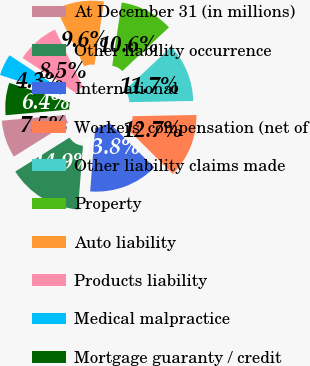Convert chart. <chart><loc_0><loc_0><loc_500><loc_500><pie_chart><fcel>At December 31 (in millions)<fcel>Other liability occurrence<fcel>International<fcel>Workers' compensation (net of<fcel>Other liability claims made<fcel>Property<fcel>Auto liability<fcel>Products liability<fcel>Medical malpractice<fcel>Mortgage guaranty / credit<nl><fcel>7.47%<fcel>14.86%<fcel>13.8%<fcel>12.74%<fcel>11.69%<fcel>10.63%<fcel>9.58%<fcel>8.52%<fcel>4.3%<fcel>6.41%<nl></chart> 